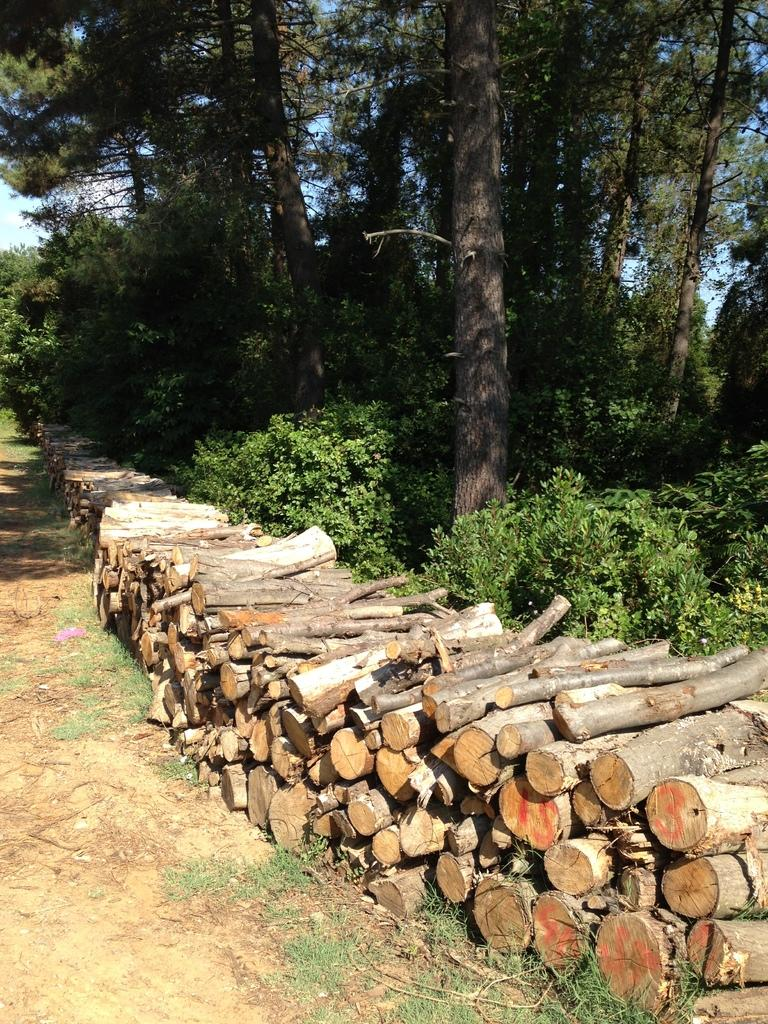What type of material is predominant in the image? There are many wooden logs in the image. What natural elements can be seen in the image? Trees are visible in the image. What type of fruit is being picked by the fireman in the image? There is no fireman or fruit present in the image; it only features wooden logs and trees. 